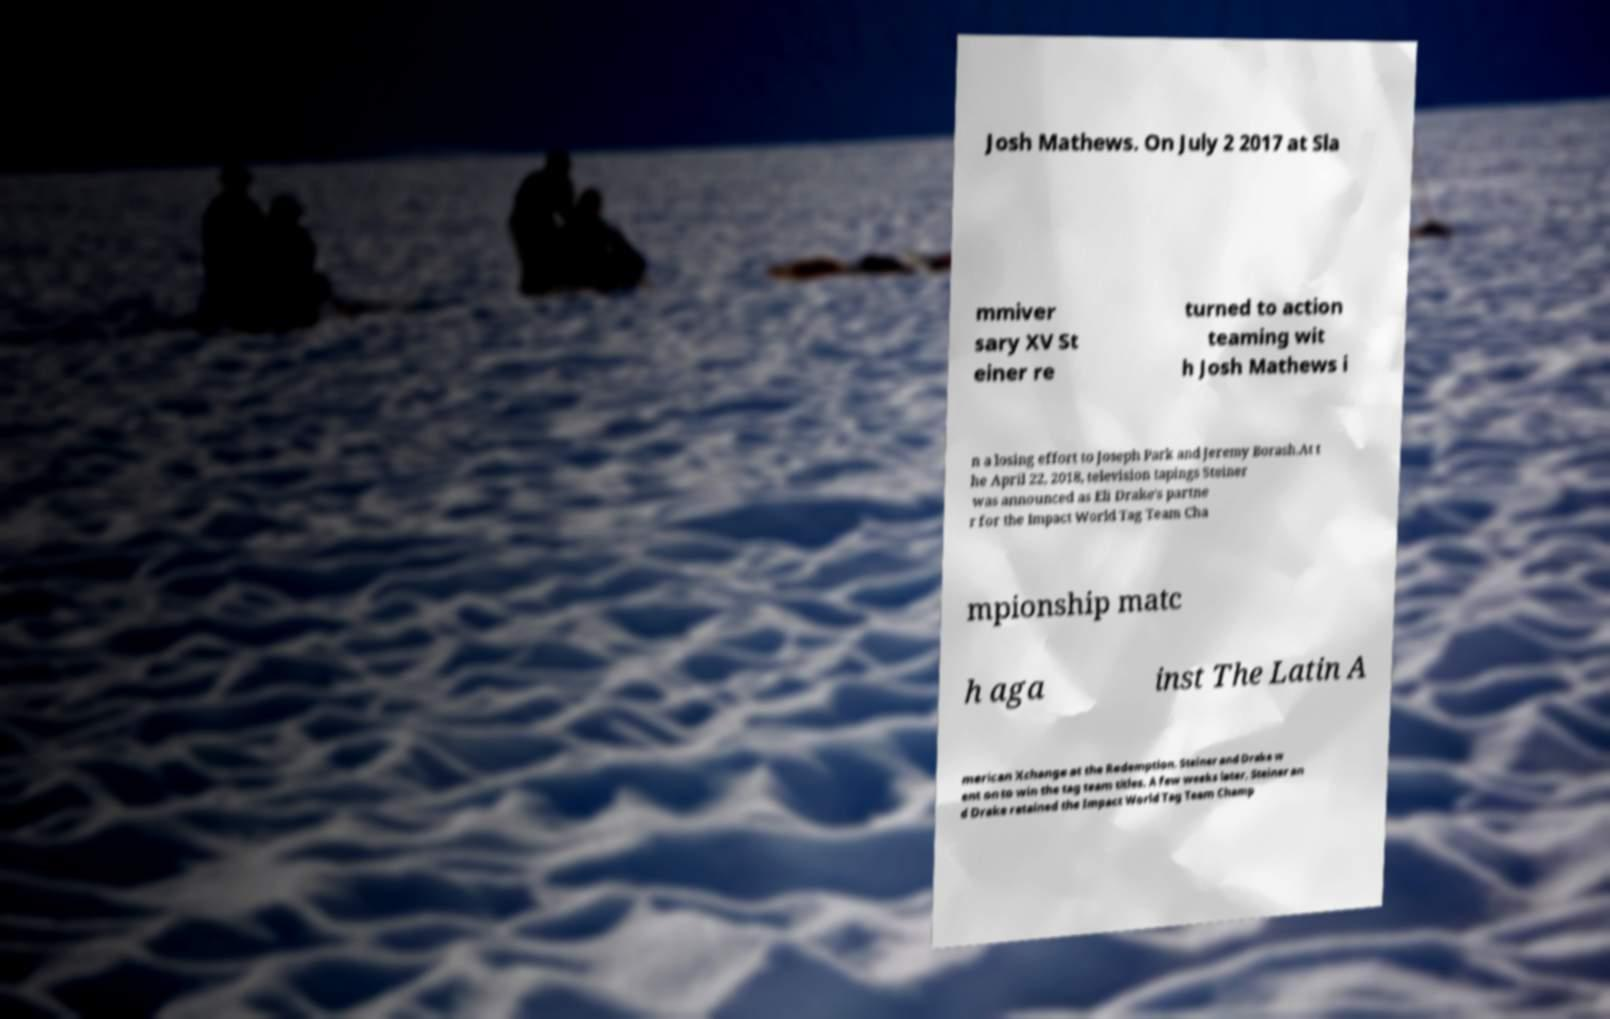Please identify and transcribe the text found in this image. Josh Mathews. On July 2 2017 at Sla mmiver sary XV St einer re turned to action teaming wit h Josh Mathews i n a losing effort to Joseph Park and Jeremy Borash.At t he April 22, 2018, television tapings Steiner was announced as Eli Drake's partne r for the Impact World Tag Team Cha mpionship matc h aga inst The Latin A merican Xchange at the Redemption. Steiner and Drake w ent on to win the tag team titles. A few weeks later, Steiner an d Drake retained the Impact World Tag Team Champ 